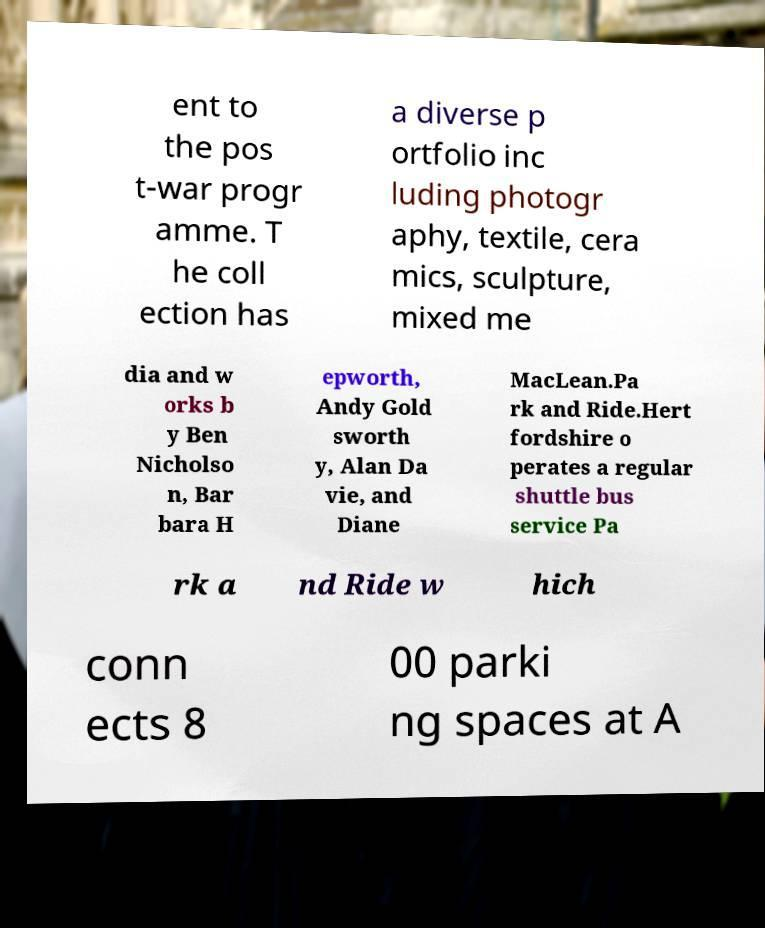Could you assist in decoding the text presented in this image and type it out clearly? ent to the pos t-war progr amme. T he coll ection has a diverse p ortfolio inc luding photogr aphy, textile, cera mics, sculpture, mixed me dia and w orks b y Ben Nicholso n, Bar bara H epworth, Andy Gold sworth y, Alan Da vie, and Diane MacLean.Pa rk and Ride.Hert fordshire o perates a regular shuttle bus service Pa rk a nd Ride w hich conn ects 8 00 parki ng spaces at A 